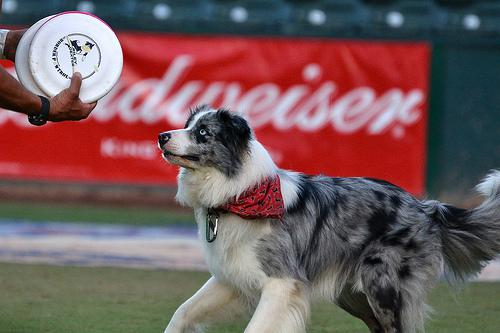Question: what beer brand logo is seen behind the dog?
Choices:
A. Budweiser.
B. Busch.
C. Blue Moon.
D. Fat Tire.
Answer with the letter. Answer: A Question: what animal is wearing a bandana?
Choices:
A. Cat.
B. Dog.
C. Pig.
D. Duck.
Answer with the letter. Answer: B Question: what colors are the dog?
Choices:
A. Black.
B. Brown.
C. Tan.
D. Grey, white.
Answer with the letter. Answer: D Question: what color are the frisbees?
Choices:
A. Yellow.
B. Red.
C. White.
D. Green.
Answer with the letter. Answer: C Question: what color watch is the man on the left wearing?
Choices:
A. Red.
B. Black.
C. Grey.
D. White.
Answer with the letter. Answer: B Question: where was this photo taken?
Choices:
A. In the woods.
B. At the ocean.
C. In the inlet.
D. In a field.
Answer with the letter. Answer: D 